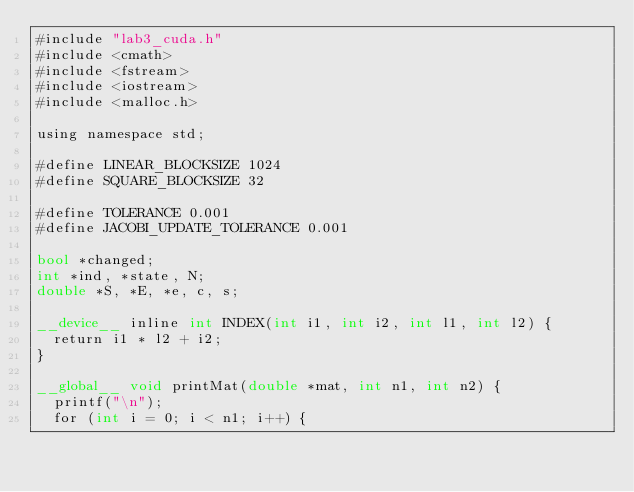Convert code to text. <code><loc_0><loc_0><loc_500><loc_500><_Cuda_>#include "lab3_cuda.h"
#include <cmath>
#include <fstream>
#include <iostream>
#include <malloc.h>

using namespace std;

#define LINEAR_BLOCKSIZE 1024
#define SQUARE_BLOCKSIZE 32

#define TOLERANCE 0.001
#define JACOBI_UPDATE_TOLERANCE 0.001

bool *changed;
int *ind, *state, N;
double *S, *E, *e, c, s;

__device__ inline int INDEX(int i1, int i2, int l1, int l2) {
  return i1 * l2 + i2;
}

__global__ void printMat(double *mat, int n1, int n2) {
  printf("\n");
  for (int i = 0; i < n1; i++) {</code> 